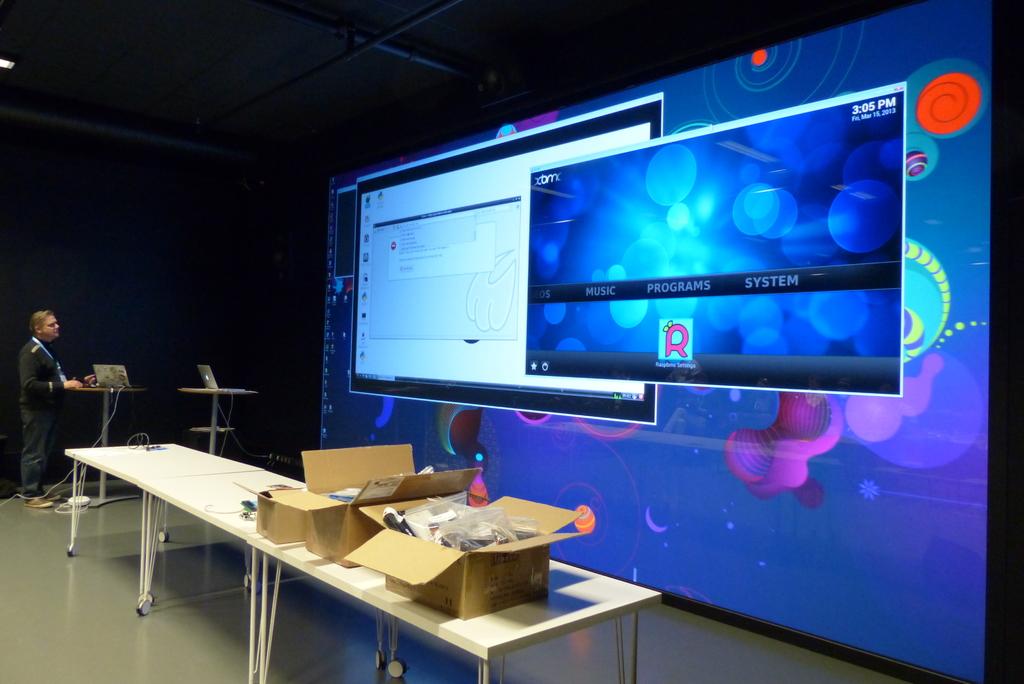What is the time on the display?
Offer a terse response. 3:05 pm. What is the word to the far right on the monitor?
Provide a short and direct response. System. 